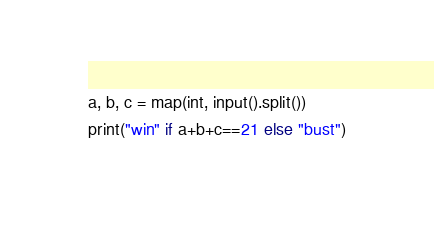<code> <loc_0><loc_0><loc_500><loc_500><_Python_>a, b, c = map(int, input().split())
print("win" if a+b+c==21 else "bust")</code> 